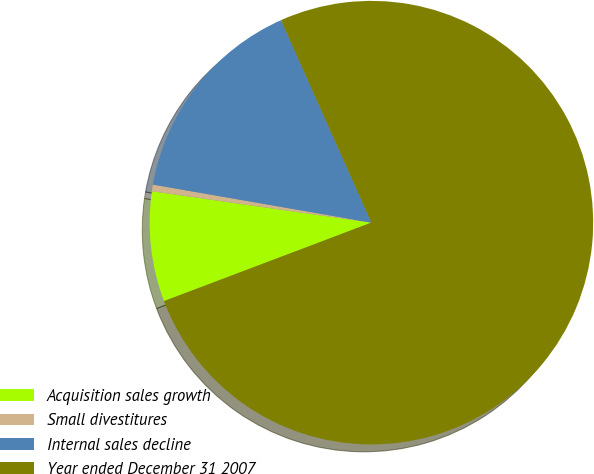Convert chart. <chart><loc_0><loc_0><loc_500><loc_500><pie_chart><fcel>Acquisition sales growth<fcel>Small divestitures<fcel>Internal sales decline<fcel>Year ended December 31 2007<nl><fcel>8.02%<fcel>0.48%<fcel>15.57%<fcel>75.93%<nl></chart> 